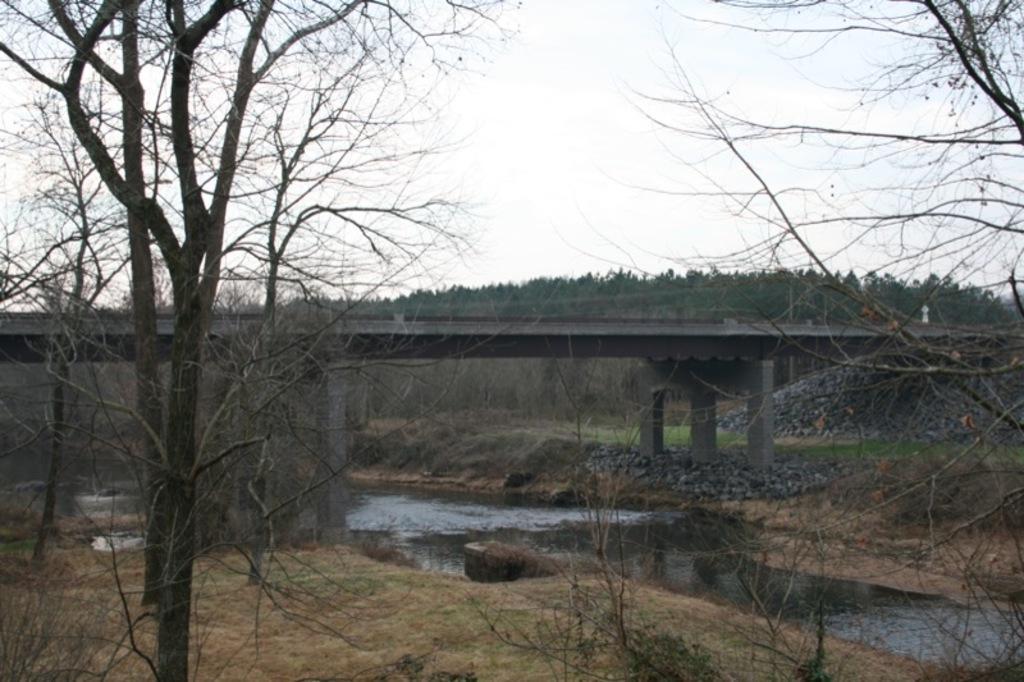Please provide a concise description of this image. In this image we can see bridge, trees, plants, water and we can also see the sky. 